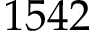Convert formula to latex. <formula><loc_0><loc_0><loc_500><loc_500>1 5 4 2</formula> 